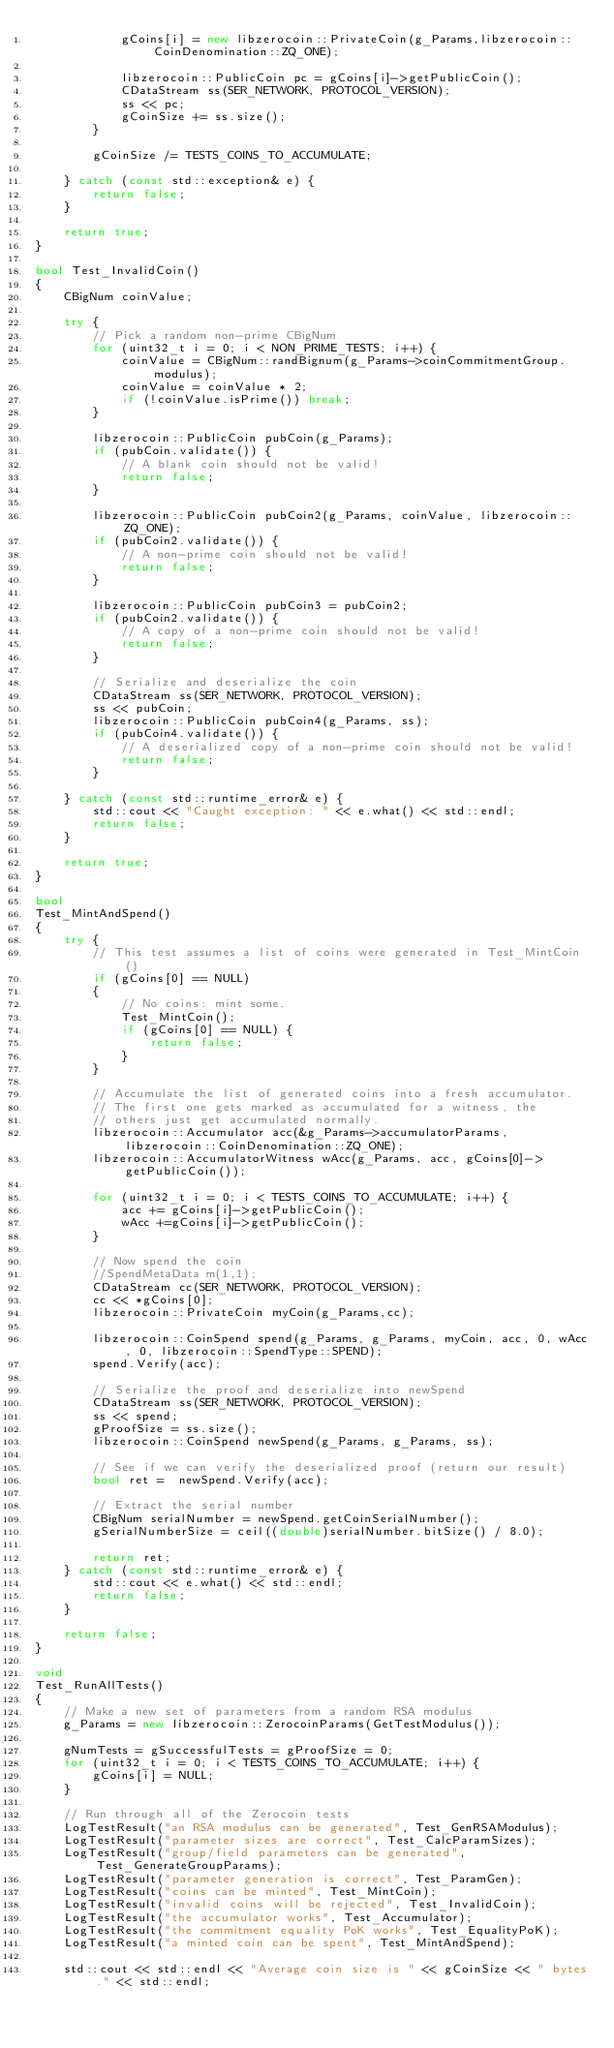Convert code to text. <code><loc_0><loc_0><loc_500><loc_500><_C++_>            gCoins[i] = new libzerocoin::PrivateCoin(g_Params,libzerocoin::CoinDenomination::ZQ_ONE);

            libzerocoin::PublicCoin pc = gCoins[i]->getPublicCoin();
            CDataStream ss(SER_NETWORK, PROTOCOL_VERSION);
            ss << pc;
            gCoinSize += ss.size();
        }

        gCoinSize /= TESTS_COINS_TO_ACCUMULATE;

    } catch (const std::exception& e) {
        return false;
    }

    return true;
}

bool Test_InvalidCoin()
{
    CBigNum coinValue;

    try {
        // Pick a random non-prime CBigNum
        for (uint32_t i = 0; i < NON_PRIME_TESTS; i++) {
            coinValue = CBigNum::randBignum(g_Params->coinCommitmentGroup.modulus);
            coinValue = coinValue * 2;
            if (!coinValue.isPrime()) break;
        }

        libzerocoin::PublicCoin pubCoin(g_Params);
        if (pubCoin.validate()) {
            // A blank coin should not be valid!
            return false;
        }

        libzerocoin::PublicCoin pubCoin2(g_Params, coinValue, libzerocoin::ZQ_ONE);
        if (pubCoin2.validate()) {
            // A non-prime coin should not be valid!
            return false;
        }

        libzerocoin::PublicCoin pubCoin3 = pubCoin2;
        if (pubCoin2.validate()) {
            // A copy of a non-prime coin should not be valid!
            return false;
        }

        // Serialize and deserialize the coin
        CDataStream ss(SER_NETWORK, PROTOCOL_VERSION);
        ss << pubCoin;
        libzerocoin::PublicCoin pubCoin4(g_Params, ss);
        if (pubCoin4.validate()) {
            // A deserialized copy of a non-prime coin should not be valid!
            return false;
        }

    } catch (const std::runtime_error& e) {
        std::cout << "Caught exception: " << e.what() << std::endl;
        return false;
    }

    return true;
}

bool
Test_MintAndSpend()
{
    try {
        // This test assumes a list of coins were generated in Test_MintCoin()
        if (gCoins[0] == NULL)
        {
            // No coins: mint some.
            Test_MintCoin();
            if (gCoins[0] == NULL) {
                return false;
            }
        }

        // Accumulate the list of generated coins into a fresh accumulator.
        // The first one gets marked as accumulated for a witness, the
        // others just get accumulated normally.
        libzerocoin::Accumulator acc(&g_Params->accumulatorParams, libzerocoin::CoinDenomination::ZQ_ONE);
        libzerocoin::AccumulatorWitness wAcc(g_Params, acc, gCoins[0]->getPublicCoin());

        for (uint32_t i = 0; i < TESTS_COINS_TO_ACCUMULATE; i++) {
            acc += gCoins[i]->getPublicCoin();
            wAcc +=gCoins[i]->getPublicCoin();
        }

        // Now spend the coin
        //SpendMetaData m(1,1);
        CDataStream cc(SER_NETWORK, PROTOCOL_VERSION);
        cc << *gCoins[0];
        libzerocoin::PrivateCoin myCoin(g_Params,cc);

        libzerocoin::CoinSpend spend(g_Params, g_Params, myCoin, acc, 0, wAcc, 0, libzerocoin::SpendType::SPEND);
        spend.Verify(acc);

        // Serialize the proof and deserialize into newSpend
        CDataStream ss(SER_NETWORK, PROTOCOL_VERSION);
        ss << spend;
        gProofSize = ss.size();
        libzerocoin::CoinSpend newSpend(g_Params, g_Params, ss);

        // See if we can verify the deserialized proof (return our result)
        bool ret =  newSpend.Verify(acc);

        // Extract the serial number
        CBigNum serialNumber = newSpend.getCoinSerialNumber();
        gSerialNumberSize = ceil((double)serialNumber.bitSize() / 8.0);

        return ret;
    } catch (const std::runtime_error& e) {
        std::cout << e.what() << std::endl;
        return false;
    }

    return false;
}

void
Test_RunAllTests()
{
    // Make a new set of parameters from a random RSA modulus
    g_Params = new libzerocoin::ZerocoinParams(GetTestModulus());

    gNumTests = gSuccessfulTests = gProofSize = 0;
    for (uint32_t i = 0; i < TESTS_COINS_TO_ACCUMULATE; i++) {
        gCoins[i] = NULL;
    }

    // Run through all of the Zerocoin tests
    LogTestResult("an RSA modulus can be generated", Test_GenRSAModulus);
    LogTestResult("parameter sizes are correct", Test_CalcParamSizes);
    LogTestResult("group/field parameters can be generated", Test_GenerateGroupParams);
    LogTestResult("parameter generation is correct", Test_ParamGen);
    LogTestResult("coins can be minted", Test_MintCoin);
    LogTestResult("invalid coins will be rejected", Test_InvalidCoin);
    LogTestResult("the accumulator works", Test_Accumulator);
    LogTestResult("the commitment equality PoK works", Test_EqualityPoK);
    LogTestResult("a minted coin can be spent", Test_MintAndSpend);

    std::cout << std::endl << "Average coin size is " << gCoinSize << " bytes." << std::endl;</code> 